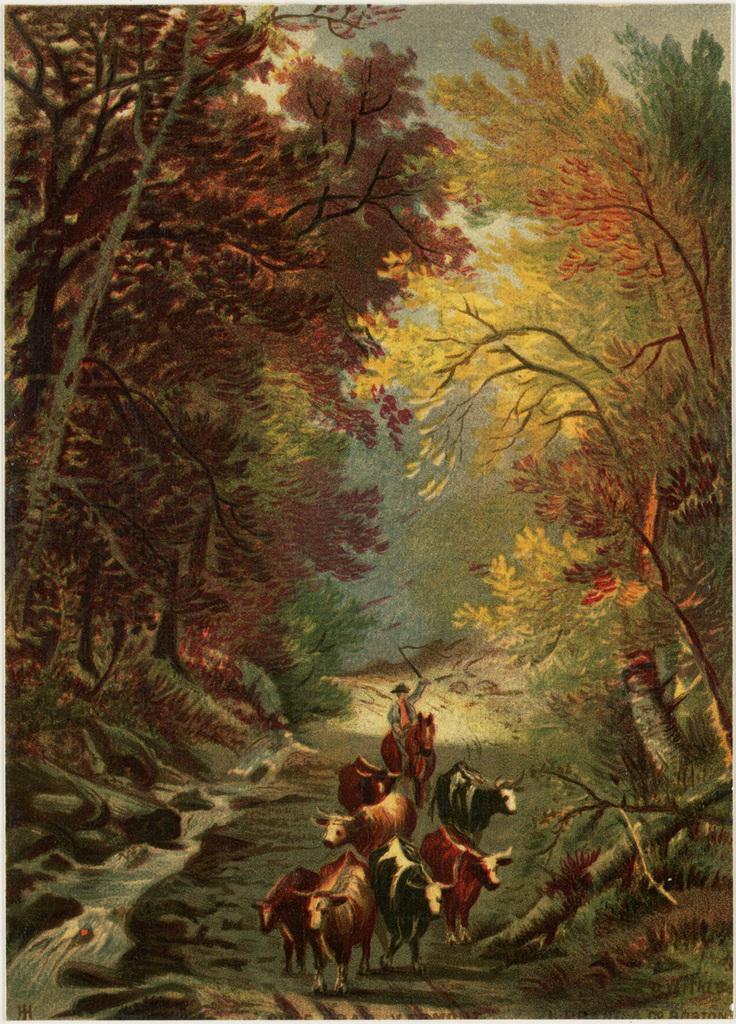How would you summarize this image in a sentence or two? In the image we can see a painting of animals and a person wearing clothes and a cap. In the painting there are many trees, grass, water and a sky. 